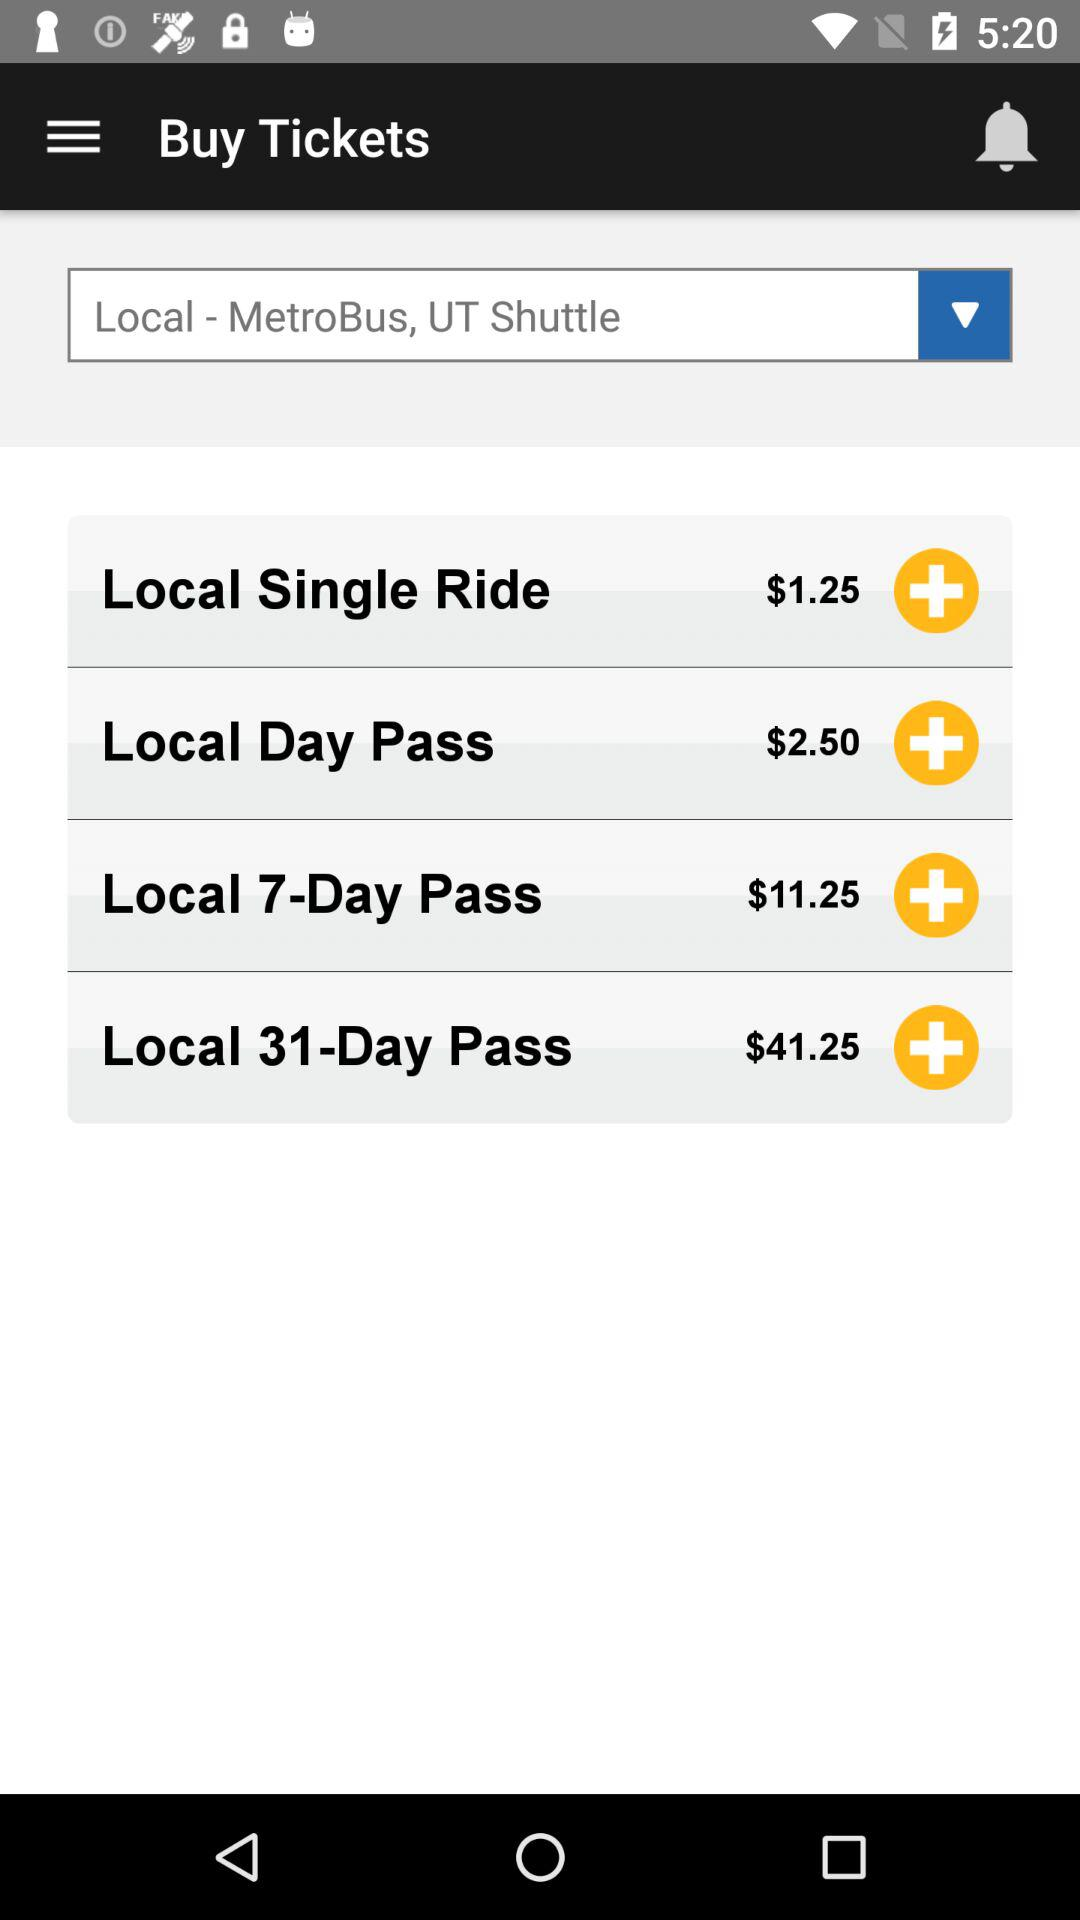What is the price of a "Local 7-Day Pass"? The price of a "Local 7-Day Pass" is $11.25. 